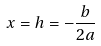<formula> <loc_0><loc_0><loc_500><loc_500>x = h = - \frac { b } { 2 a }</formula> 